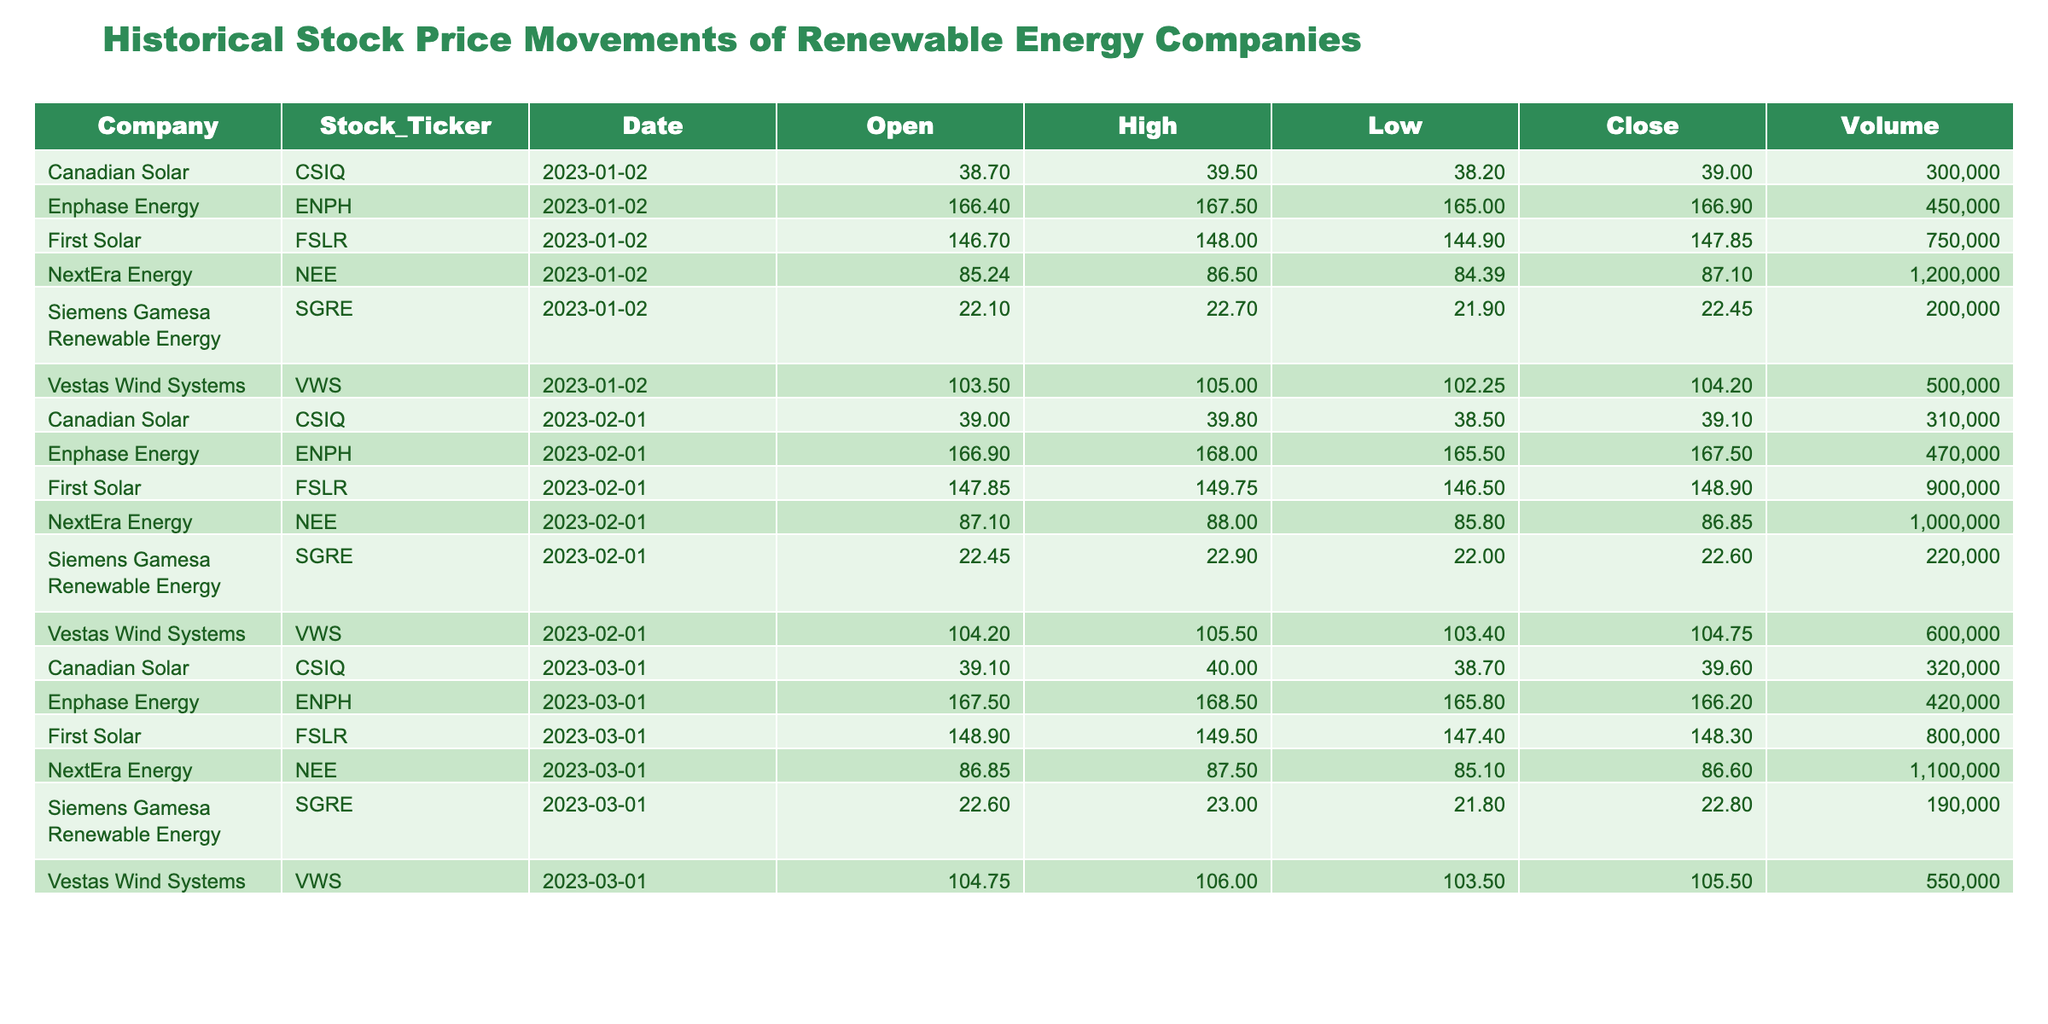What was the closing stock price of First Solar on January 2, 2023? The table indicates that on January 2, 2023, the closing stock price for First Solar (FSLR) was 147.85.
Answer: 147.85 What company had the highest stock price on March 1, 2023? On March 1, 2023, the stock prices for the companies were: NextEra Energy (86.60), Vestas Wind Systems (105.50), First Solar (148.30), Enphase Energy (166.20), Canadian Solar (39.60), and Siemens Gamesa Renewable Energy (22.80). The highest price was 166.20 for Enphase Energy.
Answer: Enphase Energy Is the stock price of Canadian Solar consistently above 38.00 from January to March 2023? The closing prices for Canadian Solar (CSIQ) over the three months were: 39.00 on January 2, 2023, 39.10 on February 1, 2023, and 39.60 on March 1, 2023. All these values are above 38.00.
Answer: Yes What was the average closing price of NextEra Energy for the three months? The closing prices for NextEra Energy were: 87.10 on January 2, 2023, 86.85 on February 1, 2023, and 86.60 on March 1, 2023. The total is (87.10 + 86.85 + 86.60) = 260.55. The average is 260.55 / 3 = 86.85.
Answer: 86.85 Which company saw the smallest closing price decline from January to March 2023? To determine the smallest decline, we analyze the closing values: First Solar went from 147.85 to 148.30 (+0.45), Vestas Wind Systems went from 104.20 to 105.50 (+1.30), and Enphase Energy went from 166.90 to 166.20 (-0.70). The smallest decline of +0.45 was for First Solar.
Answer: First Solar 